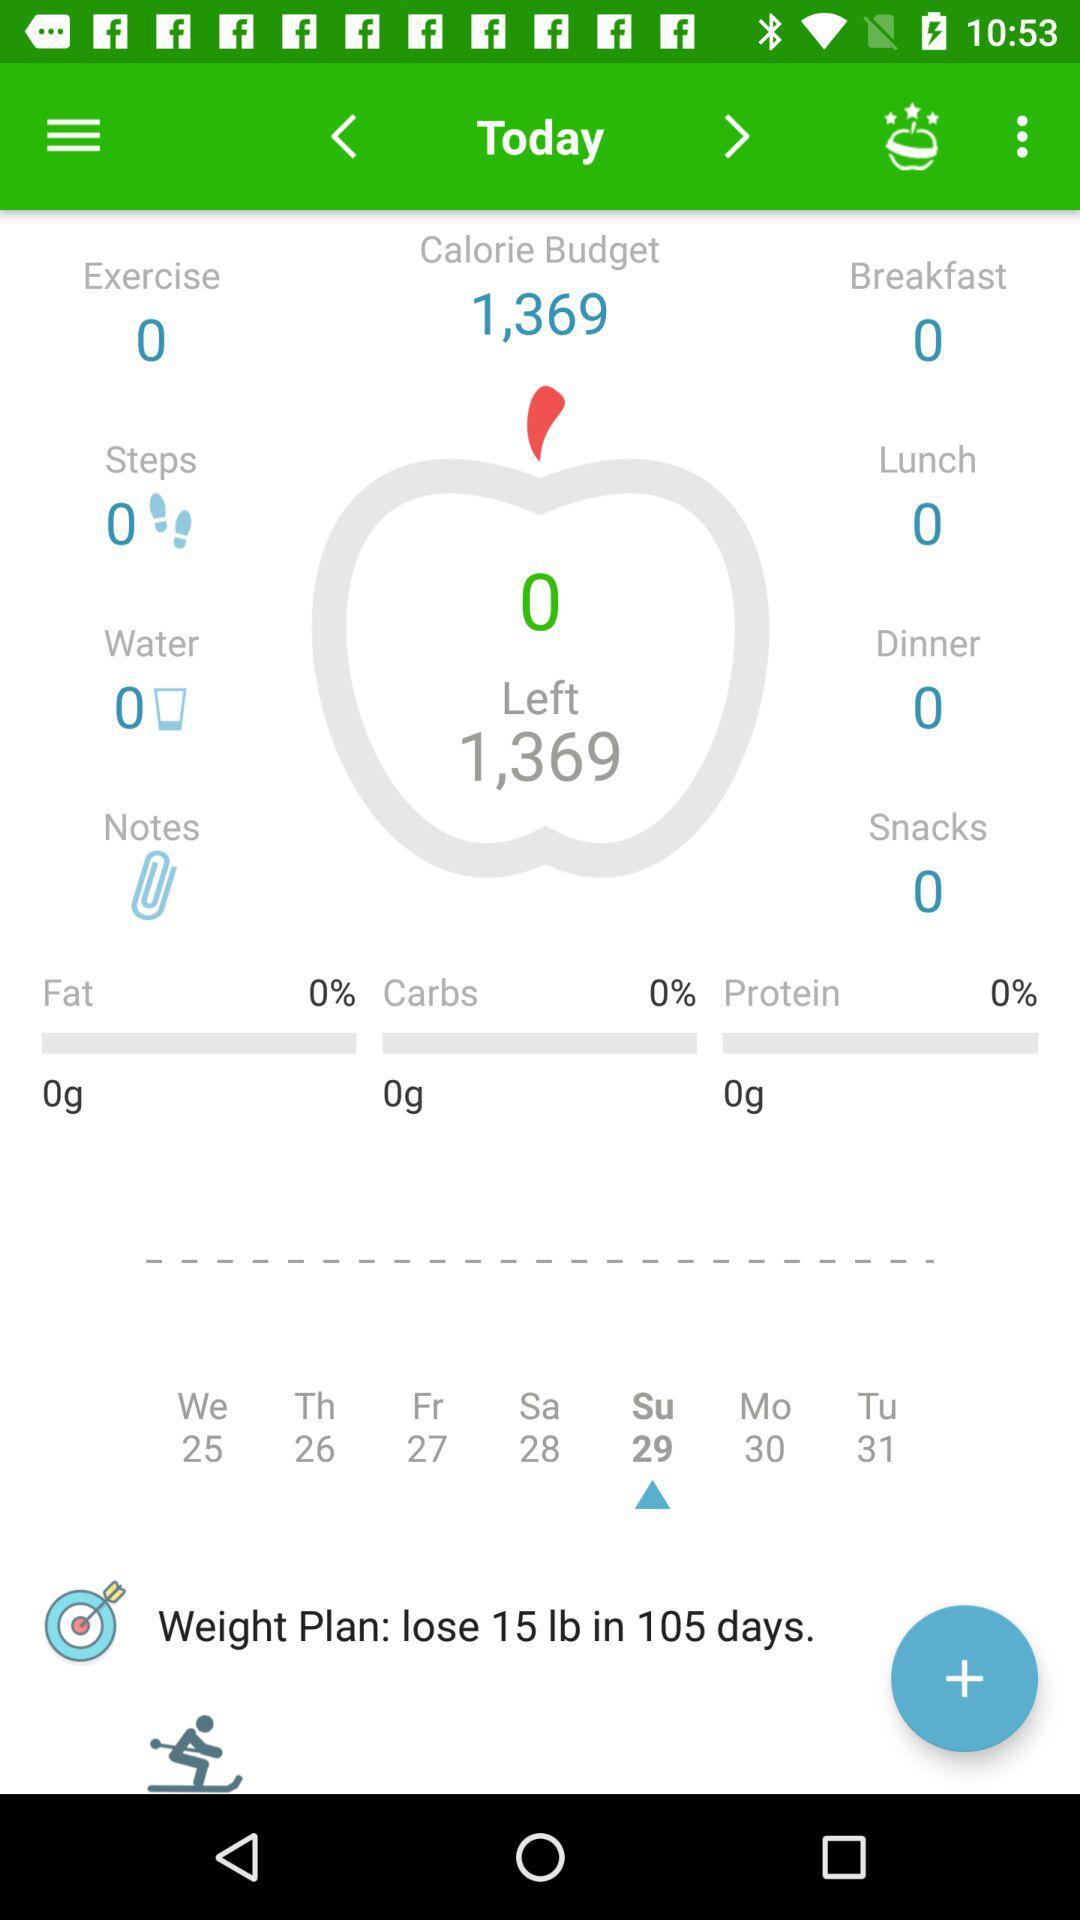What is the selected date for the weight plan? The selected date for the weight plan is Sunday 29. 